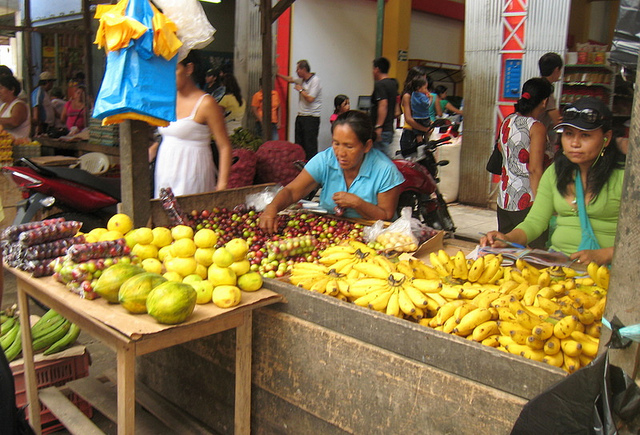<image>Which fruit is in front of the flowers? I'm unsure what fruit is in front of the flowers. It could be bananas or apples, or there may not be any fruit at all. Which fruit is in front of the flowers? I don't know which fruit is in front of the flowers. It can be either bananas, banana, apples or papaya. 